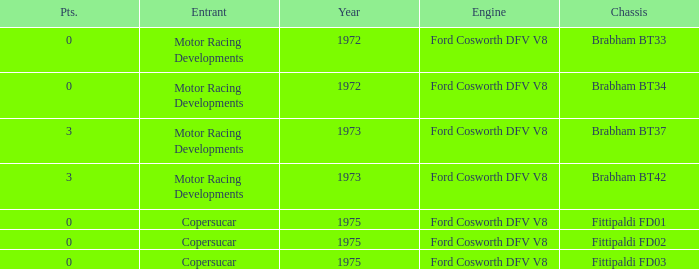Which engine from 1973 has a Brabham bt37 chassis? Ford Cosworth DFV V8. 